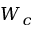<formula> <loc_0><loc_0><loc_500><loc_500>W _ { c }</formula> 